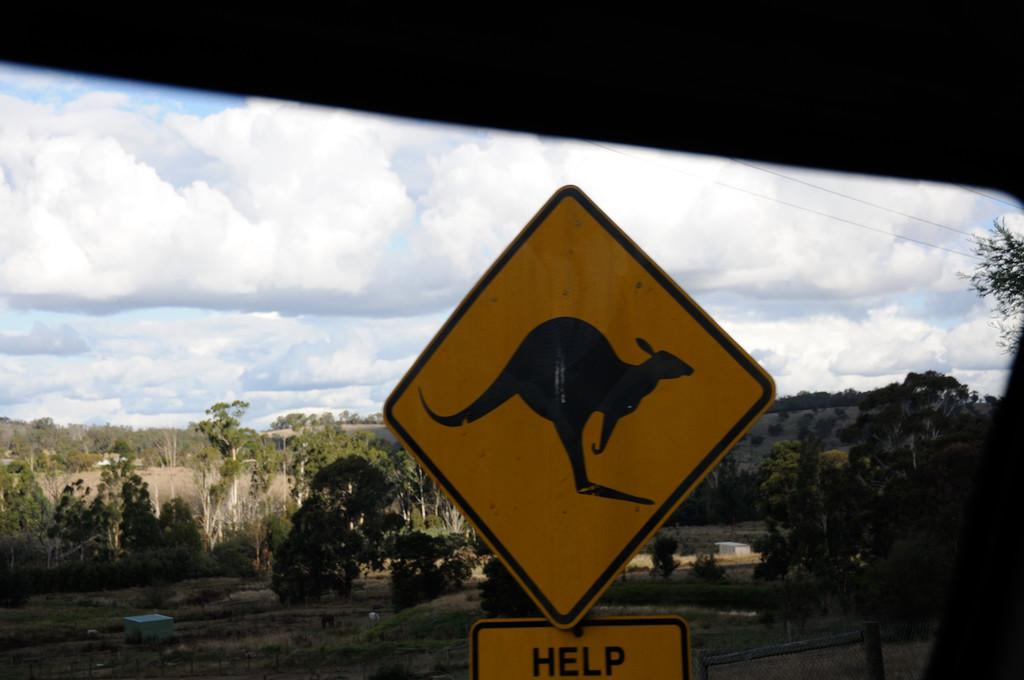What does the sign say?
Make the answer very short. Help. 